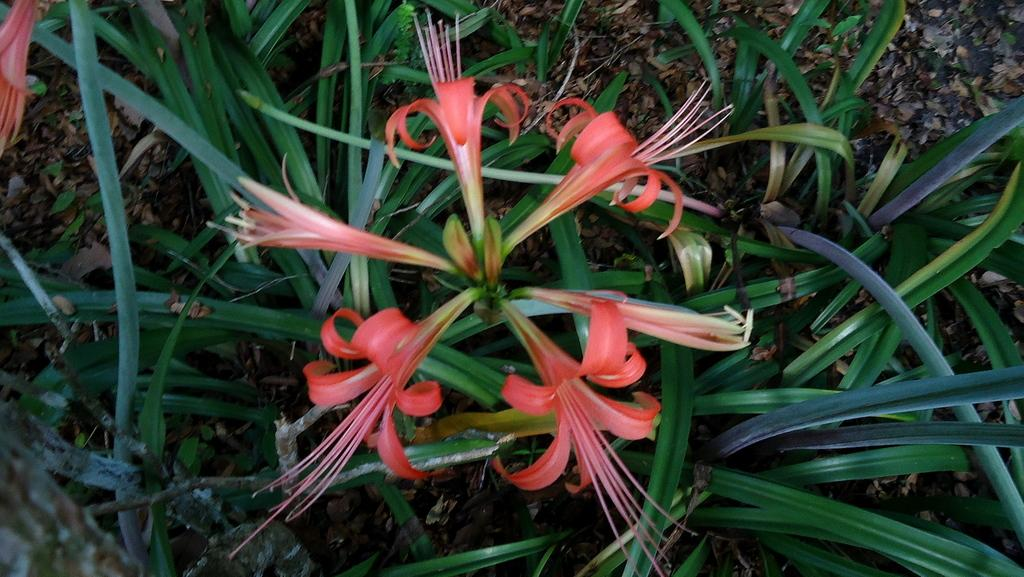What can be seen on the ground in the image? There are dried leaves on the ground in the image. What type of plants are present in the image? There are flower plants in the image. What are the flower plants producing? There are flowers in the image. What type of underwear is hanging on the flower plants in the image? There is no underwear present in the image; it only features dried leaves, flower plants, and flowers. How does the nerve system of the flower plants affect their growth in the image? The image does not provide information about the nerve system of the flower plants, so it cannot be determined how it affects their growth. 